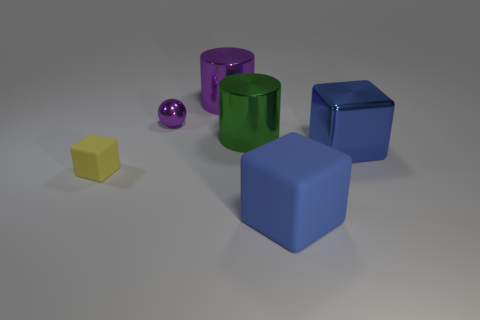There is a thing that is the same color as the big shiny cube; what is it made of?
Offer a terse response. Rubber. How big is the metal object left of the purple object behind the small purple thing?
Your answer should be compact. Small. What number of cylinders have the same color as the metallic sphere?
Provide a short and direct response. 1. There is a rubber object right of the cylinder behind the small purple ball; what shape is it?
Your answer should be very brief. Cube. How many spheres are the same material as the big green thing?
Keep it short and to the point. 1. What is the material of the blue cube that is behind the yellow thing?
Your answer should be compact. Metal. There is a big purple metallic object that is on the right side of the tiny object that is on the right side of the yellow matte cube that is left of the green thing; what is its shape?
Make the answer very short. Cylinder. Do the cylinder that is on the right side of the large purple shiny cylinder and the metallic cylinder behind the shiny ball have the same color?
Make the answer very short. No. Is the number of green metallic objects to the right of the yellow block less than the number of purple balls that are in front of the large green cylinder?
Provide a succinct answer. No. Are there any other things that are the same shape as the blue metallic object?
Your answer should be compact. Yes. 